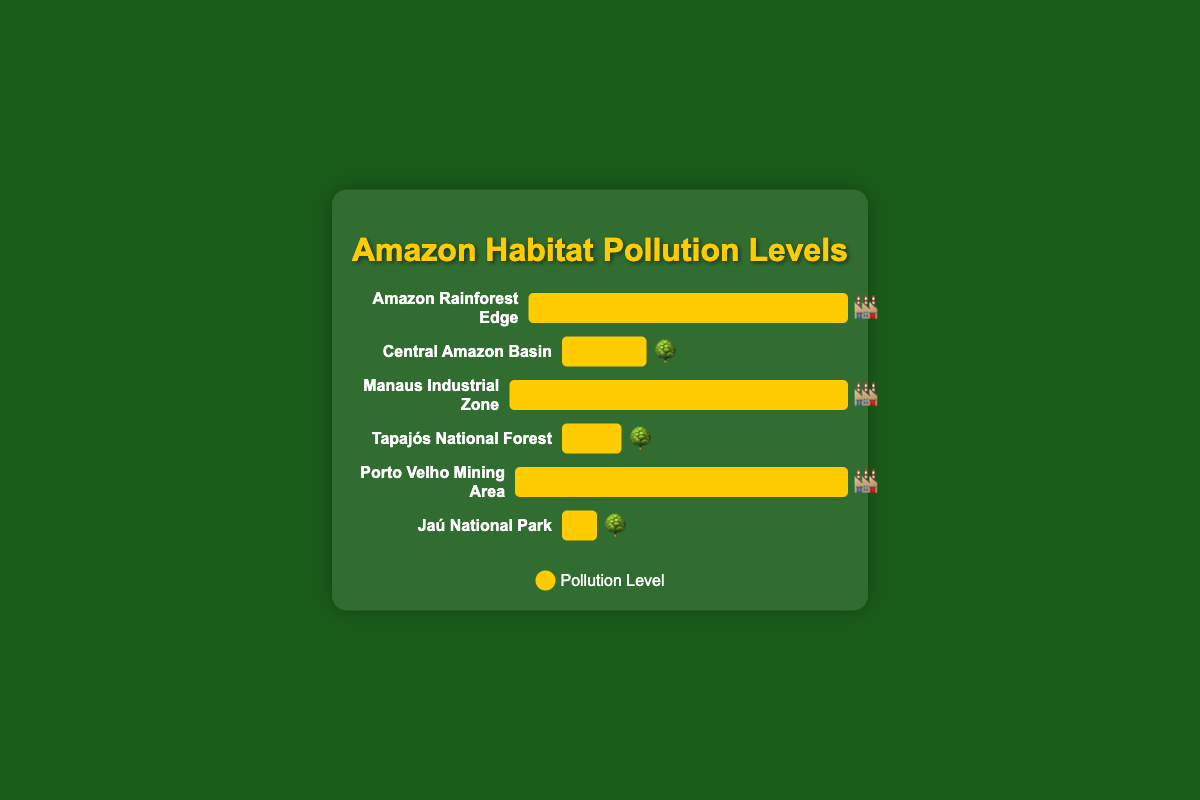What is the pollution level at the Amazon Rainforest Edge? Look at the bar corresponding to the Amazon Rainforest Edge; it shows a bar value filled to 75%
Answer: 75 Which area has the lowest pollution level? Compare all the areas, the shortest bar is associated with the Jaú National Park
Answer: Jaú National Park How many areas have pollution levels of 15% or less? Examine each bar and count those with 15% or less filling: Central Amazon Basin (15%), Tapajós National Forest (10%), and Jaú National Park (5%)
Answer: 3 Which habitat area shows the highest pollution level, and what is it? Identify the tallest bar, which in this figure is the Manaus Industrial Zone at 90%
Answer: Manaus Industrial Zone, 90 What is the pollution difference between the Manaus Industrial Zone and Tapajós National Forest? Subtract the pollution level of Tapajós National Forest (10%) from Manaus Industrial Zone (90%); 90 - 10 = 80
Answer: 80 What emoji is used to represent the Central Amazon Basin? Look at the bar label for Central Amazon Basin, which ends with an emoji 🌳
Answer: 🌳 List the areas represented with the 🏭 emoji. Identify the areas with factory emoji 🏭: Amazon Rainforest Edge, Manaus Industrial Zone, Porto Velho Mining Area
Answer: Amazon Rainforest Edge, Manaus Industrial Zone, Porto Velho Mining Area Which natural area (indicated by a 🌳 emoji) has the highest pollution level? Compare the bars with 🌳 emojis, and the highest pollution level among them is Central Amazon Basin with 15%
Answer: Central Amazon Basin Calculate the average pollution level of the industrial zones (indicated by 🏭 emoji). Add up the pollution levels for Amazon Rainforest Edge (75), Manaus Industrial Zone (90), and Porto Velho Mining Area (85) and divide by 3: (75+90+85)/3 = 83.33
Answer: 83.33 What is the total pollution level of all the areas combined? Sum the pollution levels of all areas: 75 (Amazon Rainforest Edge) + 15 (Central Amazon Basin) + 90 (Manaus Industrial Zone) + 10 (Tapajós National Forest) + 85 (Porto Velho Mining Area) + 5 (Jaú National Park); 75+15+90+10+85+5 = 280
Answer: 280 